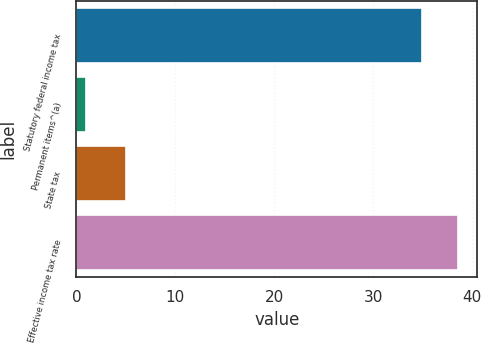<chart> <loc_0><loc_0><loc_500><loc_500><bar_chart><fcel>Statutory federal income tax<fcel>Permanent items^(a)<fcel>State tax<fcel>Effective income tax rate<nl><fcel>35<fcel>1<fcel>5<fcel>38.6<nl></chart> 